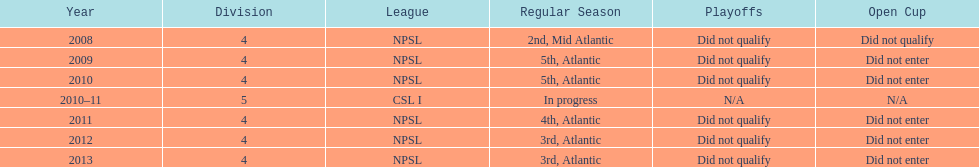For how many years were they unable to qualify for the playoffs? 6. Can you give me this table as a dict? {'header': ['Year', 'Division', 'League', 'Regular Season', 'Playoffs', 'Open Cup'], 'rows': [['2008', '4', 'NPSL', '2nd, Mid Atlantic', 'Did not qualify', 'Did not qualify'], ['2009', '4', 'NPSL', '5th, Atlantic', 'Did not qualify', 'Did not enter'], ['2010', '4', 'NPSL', '5th, Atlantic', 'Did not qualify', 'Did not enter'], ['2010–11', '5', 'CSL I', 'In progress', 'N/A', 'N/A'], ['2011', '4', 'NPSL', '4th, Atlantic', 'Did not qualify', 'Did not enter'], ['2012', '4', 'NPSL', '3rd, Atlantic', 'Did not qualify', 'Did not enter'], ['2013', '4', 'NPSL', '3rd, Atlantic', 'Did not qualify', 'Did not enter']]} 